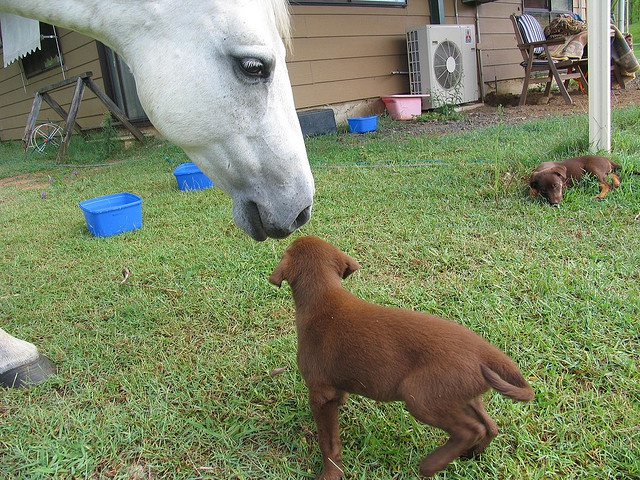Describe the objects in this image and their specific colors. I can see horse in gray, lightgray, and darkgray tones, dog in gray, maroon, and black tones, dog in gray, black, and maroon tones, chair in gray and black tones, and bowl in gray, lightblue, and blue tones in this image. 